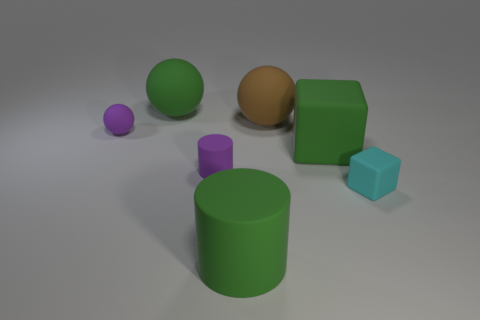Add 1 red metal cylinders. How many objects exist? 8 Subtract all spheres. How many objects are left? 4 Add 5 purple spheres. How many purple spheres are left? 6 Add 6 yellow rubber things. How many yellow rubber things exist? 6 Subtract 0 yellow spheres. How many objects are left? 7 Subtract all green metallic cubes. Subtract all purple matte balls. How many objects are left? 6 